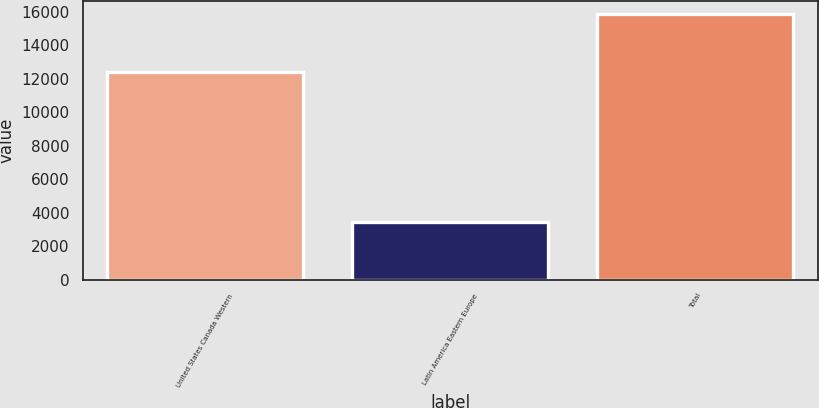<chart> <loc_0><loc_0><loc_500><loc_500><bar_chart><fcel>United States Canada Western<fcel>Latin America Eastern Europe<fcel>Total<nl><fcel>12420<fcel>3429<fcel>15849<nl></chart> 